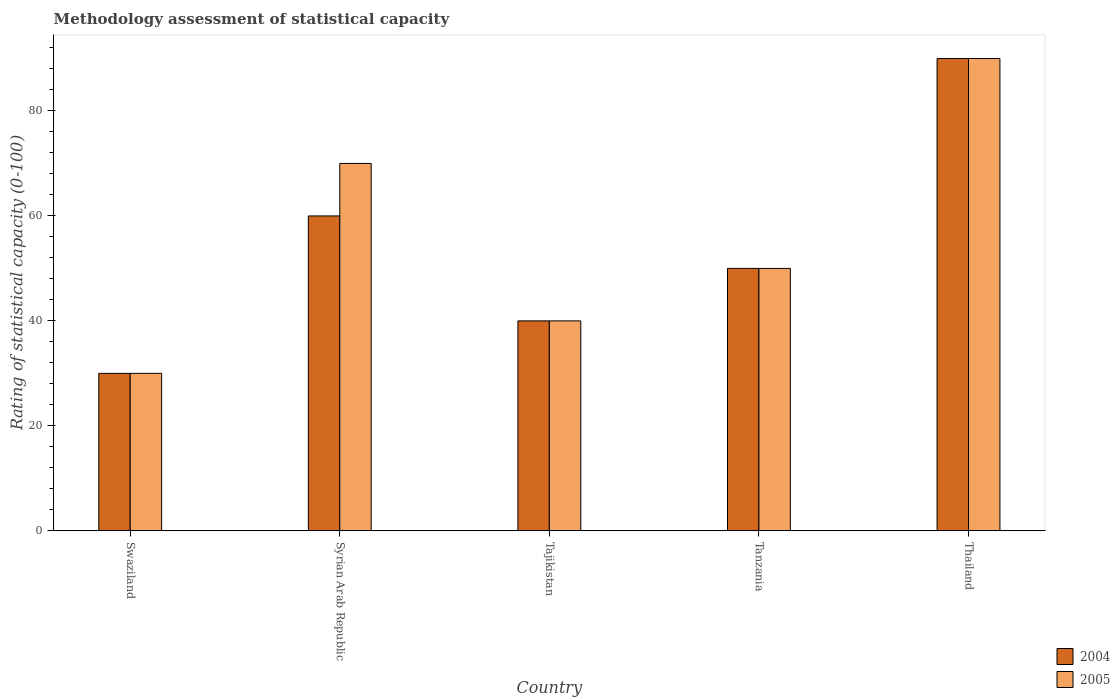How many different coloured bars are there?
Your answer should be compact. 2. Are the number of bars on each tick of the X-axis equal?
Ensure brevity in your answer.  Yes. What is the label of the 1st group of bars from the left?
Offer a very short reply. Swaziland. What is the rating of statistical capacity in 2005 in Tajikistan?
Give a very brief answer. 40. Across all countries, what is the minimum rating of statistical capacity in 2005?
Make the answer very short. 30. In which country was the rating of statistical capacity in 2004 maximum?
Offer a very short reply. Thailand. In which country was the rating of statistical capacity in 2005 minimum?
Your answer should be compact. Swaziland. What is the total rating of statistical capacity in 2004 in the graph?
Keep it short and to the point. 270. What is the difference between the rating of statistical capacity in 2004 in Swaziland and that in Tanzania?
Your response must be concise. -20. What is the difference between the rating of statistical capacity in 2004 in Syrian Arab Republic and the rating of statistical capacity in 2005 in Swaziland?
Offer a very short reply. 30. What is the average rating of statistical capacity in 2004 per country?
Offer a terse response. 54. What is the ratio of the rating of statistical capacity in 2005 in Syrian Arab Republic to that in Thailand?
Your answer should be compact. 0.78. Is the difference between the rating of statistical capacity in 2005 in Tajikistan and Tanzania greater than the difference between the rating of statistical capacity in 2004 in Tajikistan and Tanzania?
Give a very brief answer. No. What is the difference between the highest and the second highest rating of statistical capacity in 2005?
Give a very brief answer. 40. Is the sum of the rating of statistical capacity in 2004 in Tajikistan and Thailand greater than the maximum rating of statistical capacity in 2005 across all countries?
Make the answer very short. Yes. What does the 2nd bar from the right in Tajikistan represents?
Keep it short and to the point. 2004. How many bars are there?
Offer a terse response. 10. Are all the bars in the graph horizontal?
Offer a very short reply. No. How many countries are there in the graph?
Ensure brevity in your answer.  5. What is the difference between two consecutive major ticks on the Y-axis?
Your response must be concise. 20. Are the values on the major ticks of Y-axis written in scientific E-notation?
Ensure brevity in your answer.  No. Does the graph contain any zero values?
Offer a terse response. No. Does the graph contain grids?
Your answer should be very brief. No. Where does the legend appear in the graph?
Your response must be concise. Bottom right. How are the legend labels stacked?
Give a very brief answer. Vertical. What is the title of the graph?
Offer a very short reply. Methodology assessment of statistical capacity. Does "1964" appear as one of the legend labels in the graph?
Provide a short and direct response. No. What is the label or title of the X-axis?
Provide a short and direct response. Country. What is the label or title of the Y-axis?
Ensure brevity in your answer.  Rating of statistical capacity (0-100). What is the Rating of statistical capacity (0-100) of 2004 in Swaziland?
Offer a terse response. 30. What is the Rating of statistical capacity (0-100) in 2004 in Syrian Arab Republic?
Ensure brevity in your answer.  60. What is the Rating of statistical capacity (0-100) in 2004 in Tanzania?
Your answer should be very brief. 50. What is the Rating of statistical capacity (0-100) in 2005 in Tanzania?
Give a very brief answer. 50. What is the Rating of statistical capacity (0-100) in 2004 in Thailand?
Offer a terse response. 90. What is the Rating of statistical capacity (0-100) of 2005 in Thailand?
Keep it short and to the point. 90. Across all countries, what is the maximum Rating of statistical capacity (0-100) of 2004?
Keep it short and to the point. 90. Across all countries, what is the maximum Rating of statistical capacity (0-100) of 2005?
Your answer should be compact. 90. What is the total Rating of statistical capacity (0-100) in 2004 in the graph?
Your answer should be very brief. 270. What is the total Rating of statistical capacity (0-100) of 2005 in the graph?
Give a very brief answer. 280. What is the difference between the Rating of statistical capacity (0-100) of 2004 in Swaziland and that in Syrian Arab Republic?
Offer a terse response. -30. What is the difference between the Rating of statistical capacity (0-100) in 2005 in Swaziland and that in Tajikistan?
Provide a short and direct response. -10. What is the difference between the Rating of statistical capacity (0-100) of 2005 in Swaziland and that in Tanzania?
Your answer should be very brief. -20. What is the difference between the Rating of statistical capacity (0-100) in 2004 in Swaziland and that in Thailand?
Offer a very short reply. -60. What is the difference between the Rating of statistical capacity (0-100) of 2005 in Swaziland and that in Thailand?
Ensure brevity in your answer.  -60. What is the difference between the Rating of statistical capacity (0-100) of 2004 in Syrian Arab Republic and that in Tajikistan?
Keep it short and to the point. 20. What is the difference between the Rating of statistical capacity (0-100) of 2004 in Syrian Arab Republic and that in Tanzania?
Provide a succinct answer. 10. What is the difference between the Rating of statistical capacity (0-100) of 2005 in Syrian Arab Republic and that in Thailand?
Ensure brevity in your answer.  -20. What is the difference between the Rating of statistical capacity (0-100) in 2004 in Tajikistan and that in Tanzania?
Offer a terse response. -10. What is the difference between the Rating of statistical capacity (0-100) in 2004 in Tajikistan and that in Thailand?
Ensure brevity in your answer.  -50. What is the difference between the Rating of statistical capacity (0-100) in 2004 in Tanzania and that in Thailand?
Make the answer very short. -40. What is the difference between the Rating of statistical capacity (0-100) in 2004 in Swaziland and the Rating of statistical capacity (0-100) in 2005 in Tajikistan?
Keep it short and to the point. -10. What is the difference between the Rating of statistical capacity (0-100) of 2004 in Swaziland and the Rating of statistical capacity (0-100) of 2005 in Tanzania?
Provide a succinct answer. -20. What is the difference between the Rating of statistical capacity (0-100) of 2004 in Swaziland and the Rating of statistical capacity (0-100) of 2005 in Thailand?
Offer a very short reply. -60. What is the difference between the Rating of statistical capacity (0-100) in 2004 in Syrian Arab Republic and the Rating of statistical capacity (0-100) in 2005 in Tajikistan?
Keep it short and to the point. 20. What is the difference between the Rating of statistical capacity (0-100) of 2004 in Syrian Arab Republic and the Rating of statistical capacity (0-100) of 2005 in Tanzania?
Give a very brief answer. 10. What is the difference between the Rating of statistical capacity (0-100) of 2004 in Tajikistan and the Rating of statistical capacity (0-100) of 2005 in Thailand?
Provide a succinct answer. -50. What is the average Rating of statistical capacity (0-100) in 2005 per country?
Give a very brief answer. 56. What is the difference between the Rating of statistical capacity (0-100) in 2004 and Rating of statistical capacity (0-100) in 2005 in Syrian Arab Republic?
Offer a very short reply. -10. What is the difference between the Rating of statistical capacity (0-100) of 2004 and Rating of statistical capacity (0-100) of 2005 in Tanzania?
Ensure brevity in your answer.  0. What is the difference between the Rating of statistical capacity (0-100) in 2004 and Rating of statistical capacity (0-100) in 2005 in Thailand?
Your response must be concise. 0. What is the ratio of the Rating of statistical capacity (0-100) of 2004 in Swaziland to that in Syrian Arab Republic?
Provide a succinct answer. 0.5. What is the ratio of the Rating of statistical capacity (0-100) of 2005 in Swaziland to that in Syrian Arab Republic?
Your answer should be compact. 0.43. What is the ratio of the Rating of statistical capacity (0-100) of 2005 in Swaziland to that in Tanzania?
Your response must be concise. 0.6. What is the ratio of the Rating of statistical capacity (0-100) in 2004 in Syrian Arab Republic to that in Tajikistan?
Ensure brevity in your answer.  1.5. What is the ratio of the Rating of statistical capacity (0-100) of 2005 in Syrian Arab Republic to that in Tajikistan?
Give a very brief answer. 1.75. What is the ratio of the Rating of statistical capacity (0-100) in 2005 in Syrian Arab Republic to that in Thailand?
Your answer should be compact. 0.78. What is the ratio of the Rating of statistical capacity (0-100) of 2004 in Tajikistan to that in Tanzania?
Give a very brief answer. 0.8. What is the ratio of the Rating of statistical capacity (0-100) of 2004 in Tajikistan to that in Thailand?
Offer a very short reply. 0.44. What is the ratio of the Rating of statistical capacity (0-100) of 2005 in Tajikistan to that in Thailand?
Provide a succinct answer. 0.44. What is the ratio of the Rating of statistical capacity (0-100) in 2004 in Tanzania to that in Thailand?
Your answer should be very brief. 0.56. What is the ratio of the Rating of statistical capacity (0-100) in 2005 in Tanzania to that in Thailand?
Your answer should be very brief. 0.56. What is the difference between the highest and the lowest Rating of statistical capacity (0-100) in 2005?
Offer a very short reply. 60. 